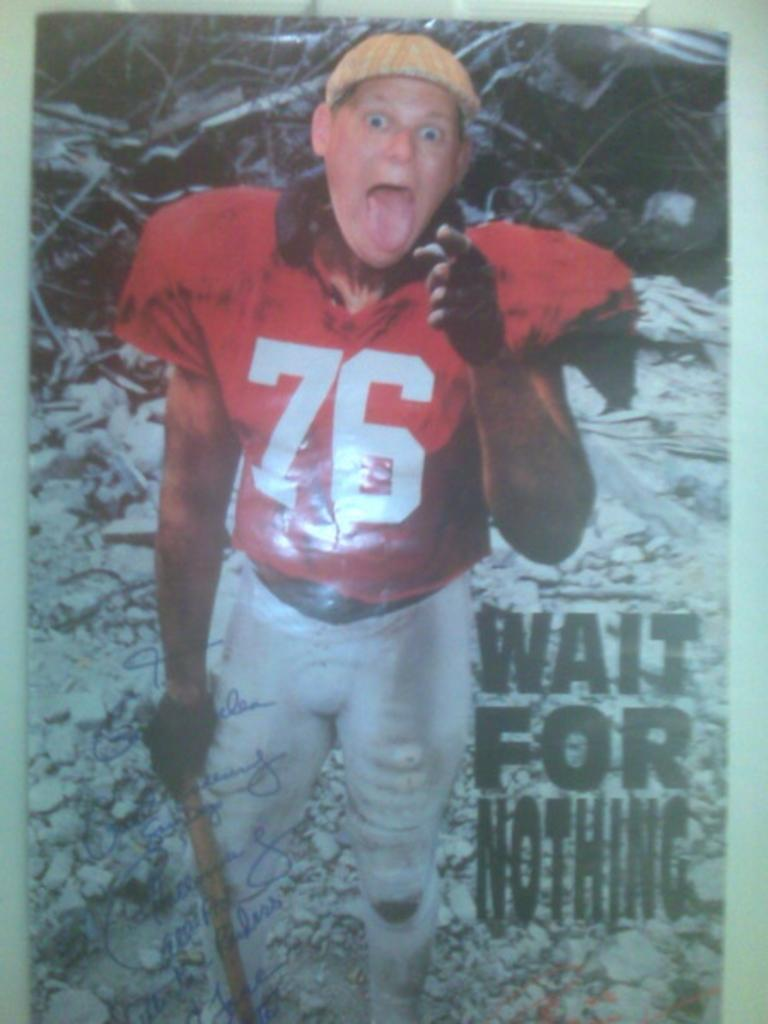<image>
Give a short and clear explanation of the subsequent image. The man pictured on this poster waits for nothing. 